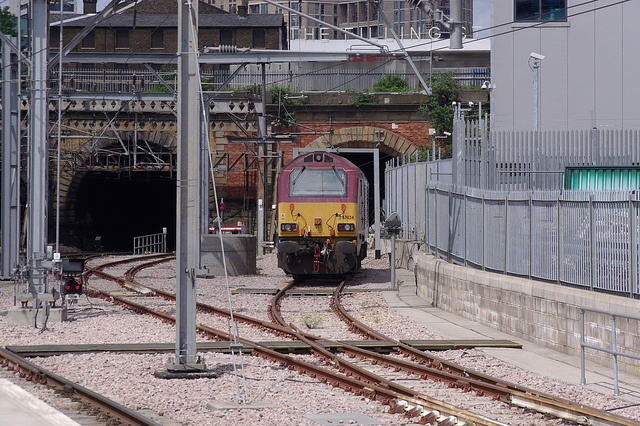Describe the objects in this image and their specific colors. I can see a train in darkgray, black, gray, and brown tones in this image. 